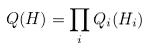Convert formula to latex. <formula><loc_0><loc_0><loc_500><loc_500>Q ( H ) = \prod _ { i } Q _ { i } ( H _ { i } )</formula> 